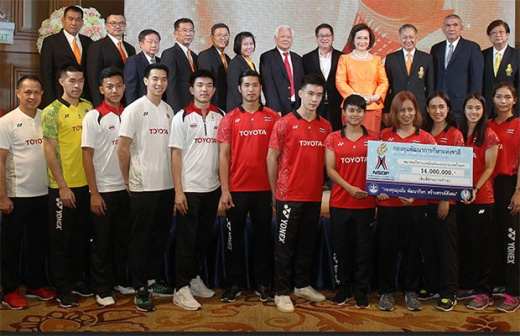Can you describe the attire and roles of the individuals in the image? The individuals in the front row are wearing sports uniforms with the Toyota logo, indicating they could be athletes or sports team members. Their colorful sportswear contrasts sharply with the formal attire of the individuals in the back row, who are dressed in suits and formal dresses. This suggests that the back row comprises officials, executives, or dignitaries. This attire dichotomy emphasizes the nature of the event, blending formal acknowledgment with athletic celebration. What does the presence of a large check imply about the event? The large check implies that a considerable monetary award or donation is being presented. Such checks are often used in promotional or ceremonial contexts to mark significant financial contributions, publicity events, or sponsorship deals. This particular check's amount, 16,000,000 Thai Baht, highlights the importance of the award or the significance of the sponsorship. 